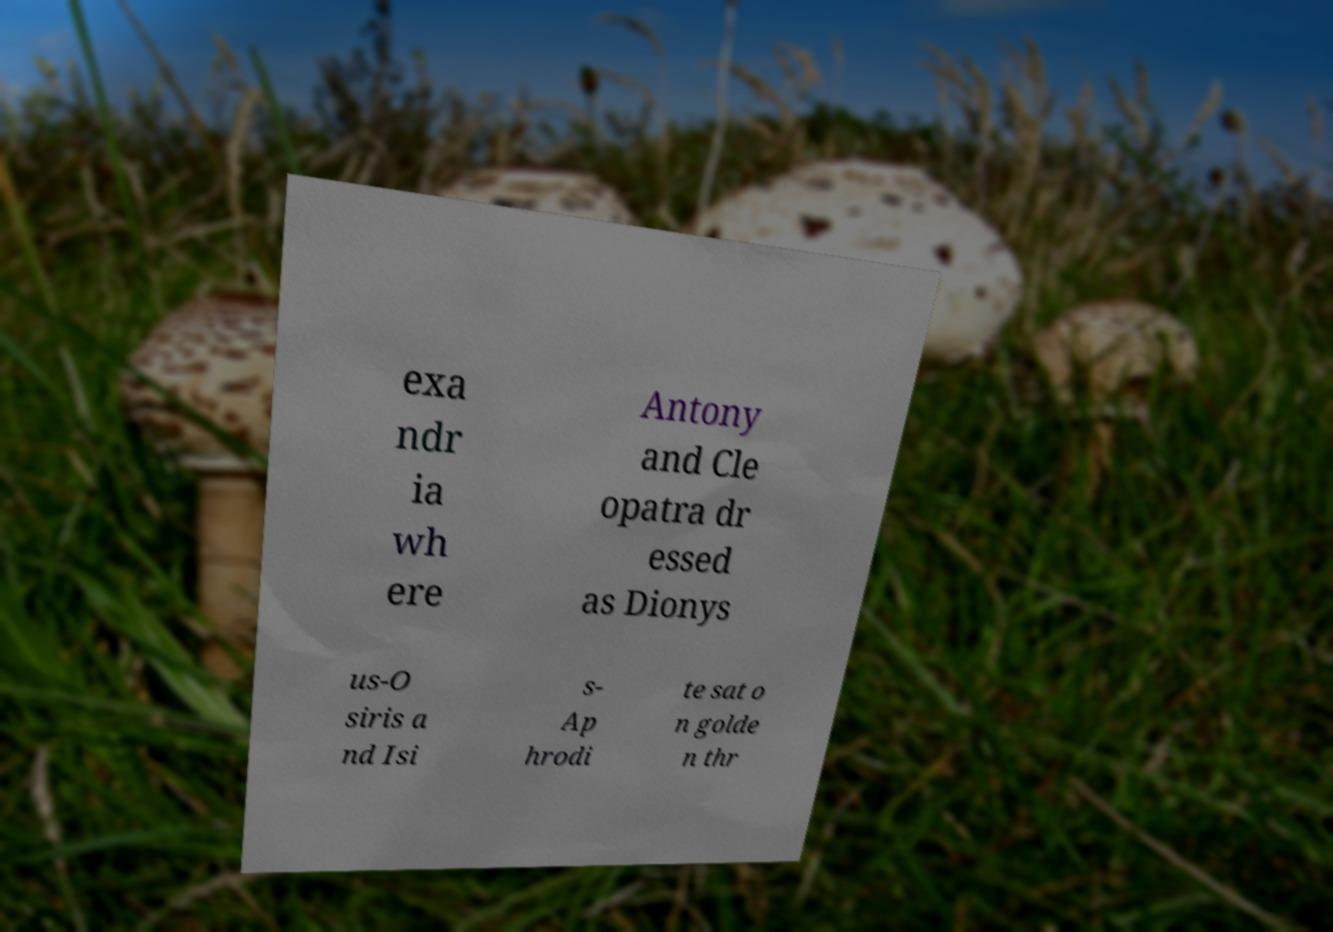I need the written content from this picture converted into text. Can you do that? exa ndr ia wh ere Antony and Cle opatra dr essed as Dionys us-O siris a nd Isi s- Ap hrodi te sat o n golde n thr 